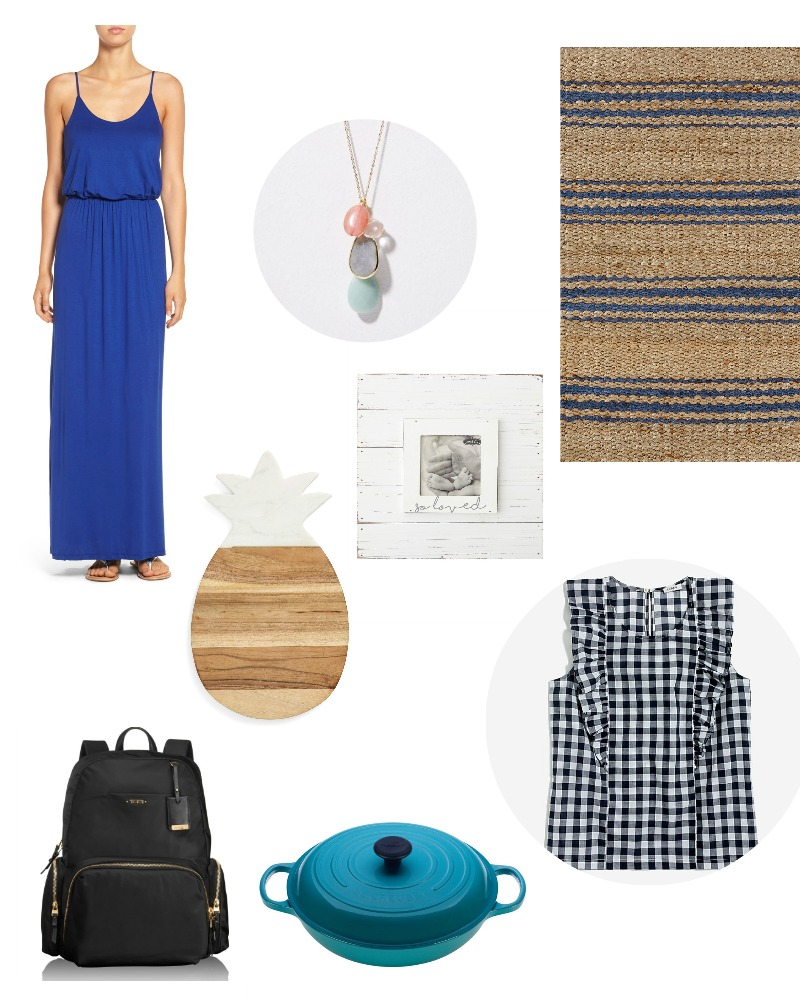Considering the assortment of items in the image, what could be the common thread or theme that connects them, and how might these items be collectively used in a specific setting or event? The common thread among these items seems to be centered around a cozy, family-oriented lifestyle with a touch of elegance. The blue dress and checkered top offer stylish options for casual yet refined home wear or outings. The necklace brings an element of personal style and adornment, enhancing the outfits. The jute rug and wooden pineapple cutting board point towards a natural and rustic home decor, perfect for creating a warm and inviting living space or kitchen. The black backpack, with its gold details, serves both functional and aesthetic purposes, suitable for carrying essentials for a day out or casual gatherings. The black and white photo in a rustic frame adds a personal touch, suggesting a family-focused environment. Lastly, the teal cast iron pot is a valuable kitchen tool, ideal for preparing meals at home. Collectively, these items can be used to create a setting where comfort, style, and family warmth take center stage, possibly for a relaxed family day at home or a cozy get-together with loved ones. 